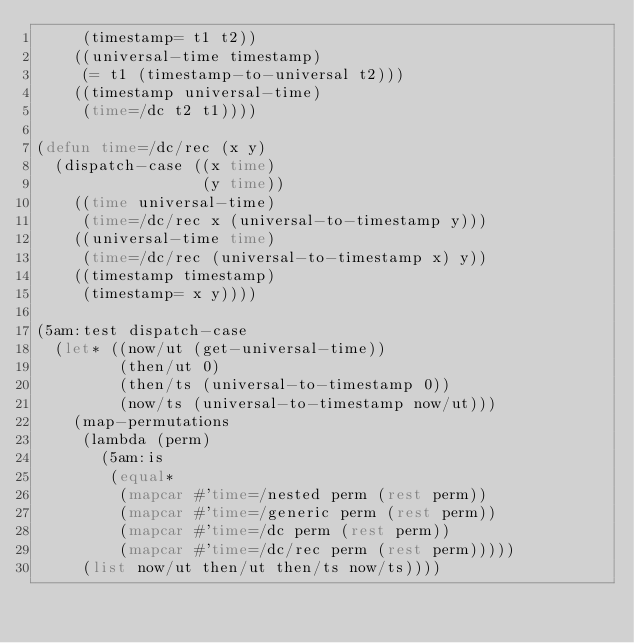<code> <loc_0><loc_0><loc_500><loc_500><_Lisp_>     (timestamp= t1 t2))
    ((universal-time timestamp)
     (= t1 (timestamp-to-universal t2)))
    ((timestamp universal-time)
     (time=/dc t2 t1))))

(defun time=/dc/rec (x y)
  (dispatch-case ((x time)
                  (y time))
    ((time universal-time)
     (time=/dc/rec x (universal-to-timestamp y)))
    ((universal-time time)
     (time=/dc/rec (universal-to-timestamp x) y))
    ((timestamp timestamp)
     (timestamp= x y))))

(5am:test dispatch-case
  (let* ((now/ut (get-universal-time))
         (then/ut 0)
         (then/ts (universal-to-timestamp 0))
         (now/ts (universal-to-timestamp now/ut)))
    (map-permutations
     (lambda (perm)
       (5am:is
        (equal*
         (mapcar #'time=/nested perm (rest perm))
         (mapcar #'time=/generic perm (rest perm))
         (mapcar #'time=/dc perm (rest perm))
         (mapcar #'time=/dc/rec perm (rest perm)))))
     (list now/ut then/ut then/ts now/ts))))
</code> 